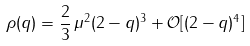Convert formula to latex. <formula><loc_0><loc_0><loc_500><loc_500>\rho ( q ) = \frac { 2 } { 3 } \, \mu ^ { 2 } ( 2 - q ) ^ { 3 } + \mathcal { O } [ ( 2 - q ) ^ { 4 } ]</formula> 